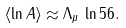<formula> <loc_0><loc_0><loc_500><loc_500>\langle \ln A \rangle \approx \Lambda _ { \mu } \, \ln 5 6 .</formula> 